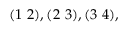Convert formula to latex. <formula><loc_0><loc_0><loc_500><loc_500>( 1 2 ) , ( 2 3 ) , ( 3 4 ) ,</formula> 